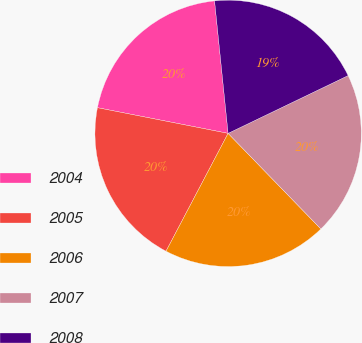Convert chart to OTSL. <chart><loc_0><loc_0><loc_500><loc_500><pie_chart><fcel>2004<fcel>2005<fcel>2006<fcel>2007<fcel>2008<nl><fcel>20.29%<fcel>20.37%<fcel>19.98%<fcel>19.88%<fcel>19.48%<nl></chart> 